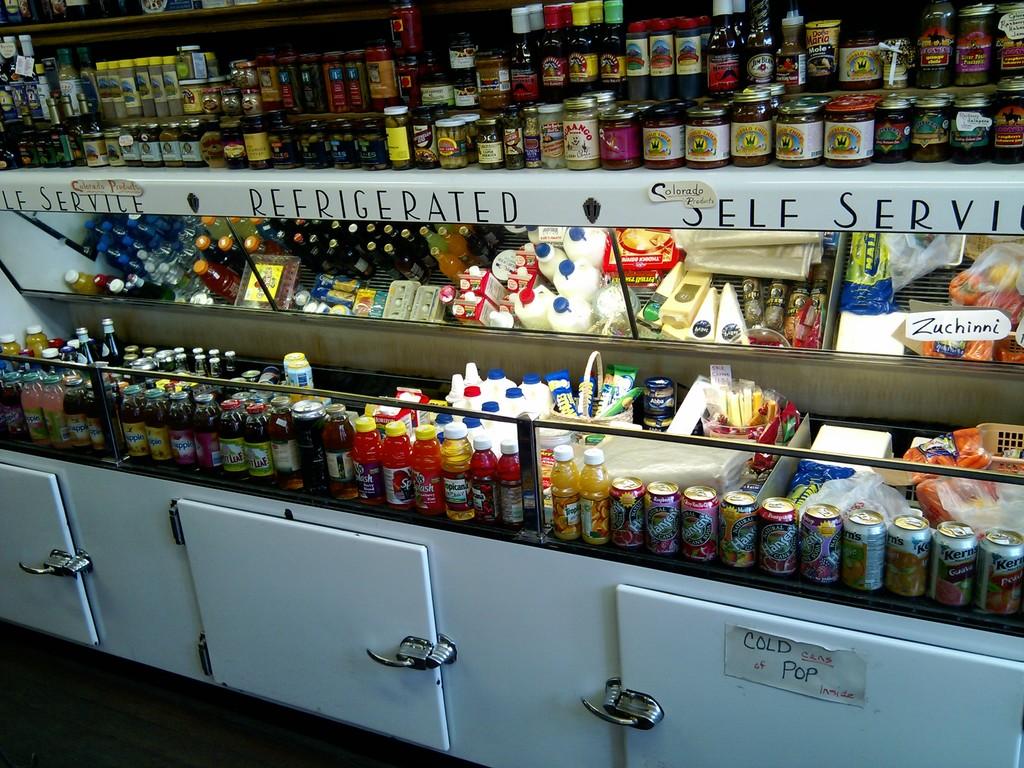Is the pop cold or hot?
Your answer should be very brief. Cold. Is this a self service place?
Your response must be concise. Yes. 